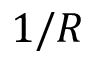Convert formula to latex. <formula><loc_0><loc_0><loc_500><loc_500>1 / R</formula> 